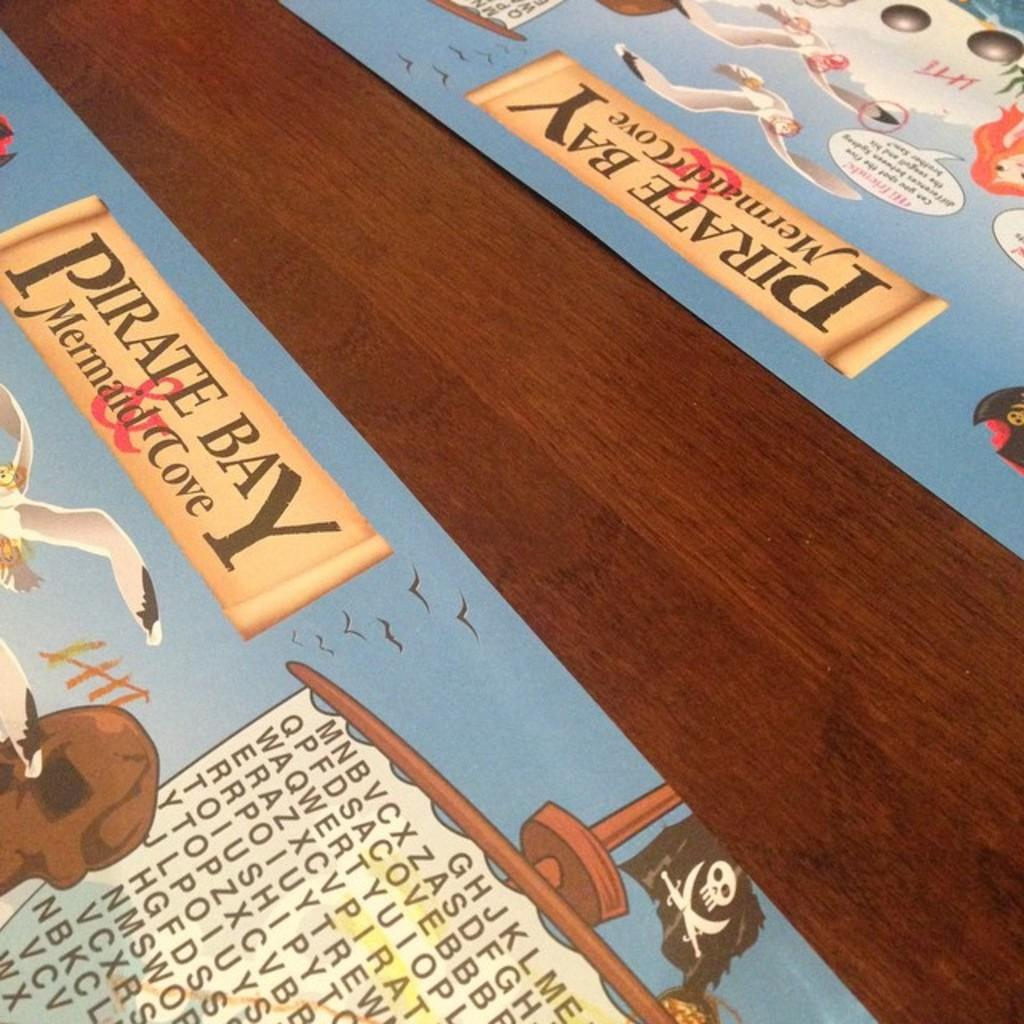<image>
Offer a succinct explanation of the picture presented. A wooden table with two Pirate Bay Mermaid Cove place mats on it. 